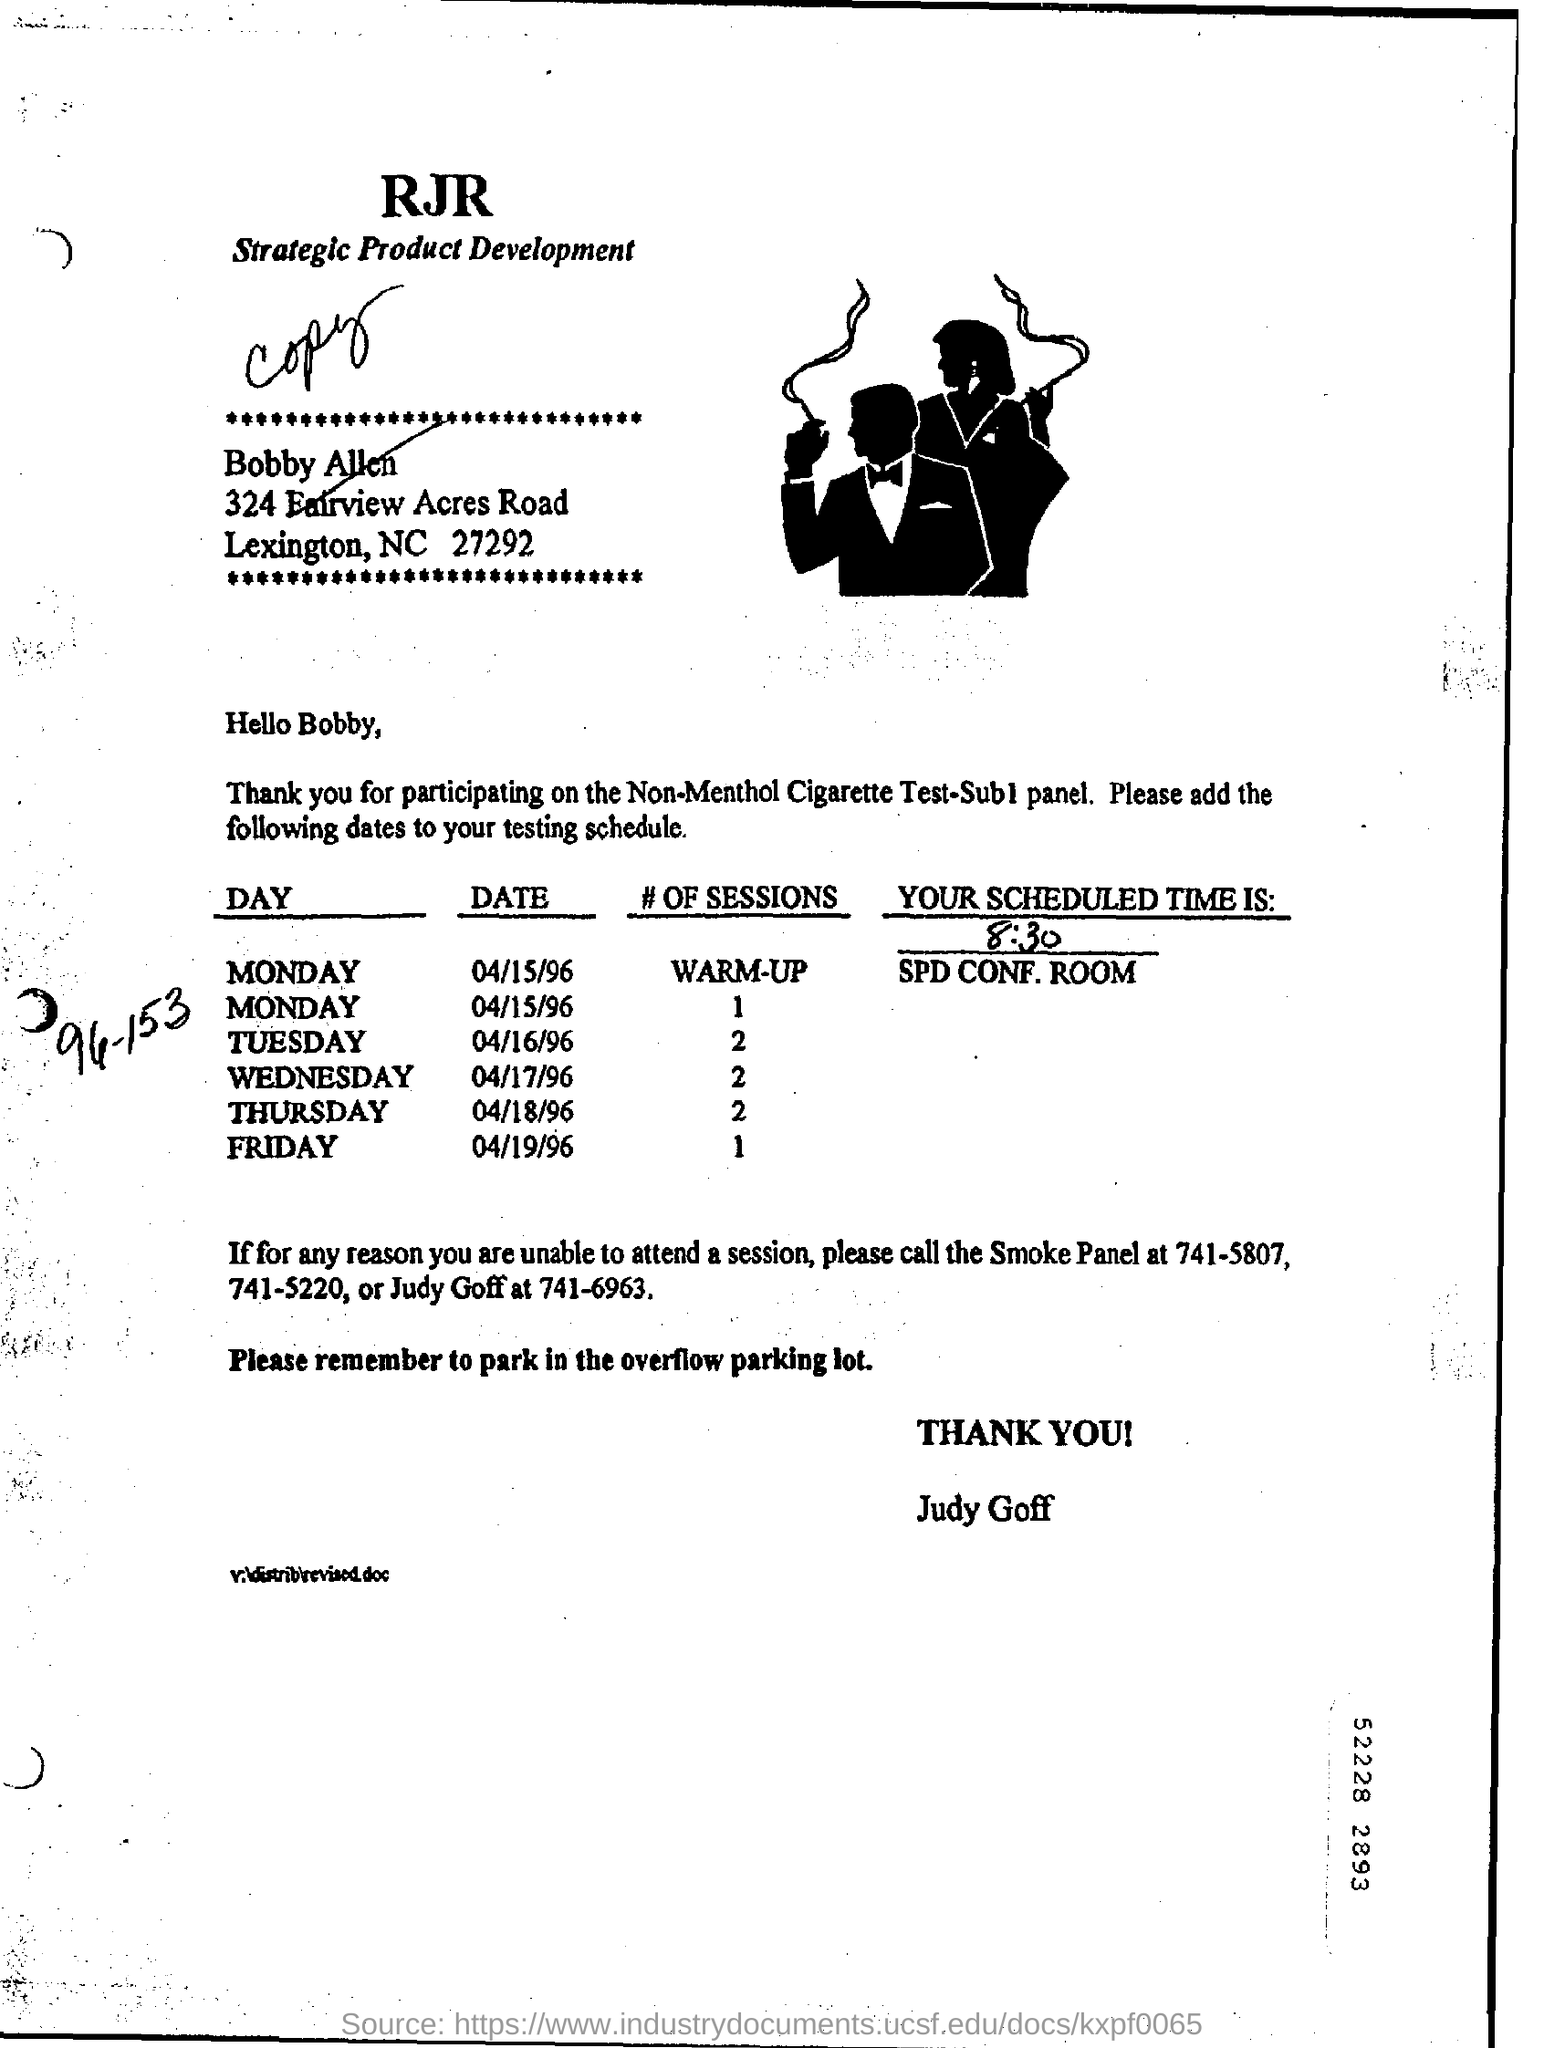What is the scheduled timing for the session?
Provide a succinct answer. 8:30. How many number of sessions are scheduled on Tuesday?
Provide a short and direct response. 2. How many number of sessions are scheduled on Friday?
Your answer should be compact. 1. How many number of sessions are scheduled on Thursday?
Ensure brevity in your answer.  2. How many number of sessions are scheduled on wednesday?
Your response must be concise. 2. Where are the sessions scheduled?
Your answer should be compact. SPD Conf. Room. 